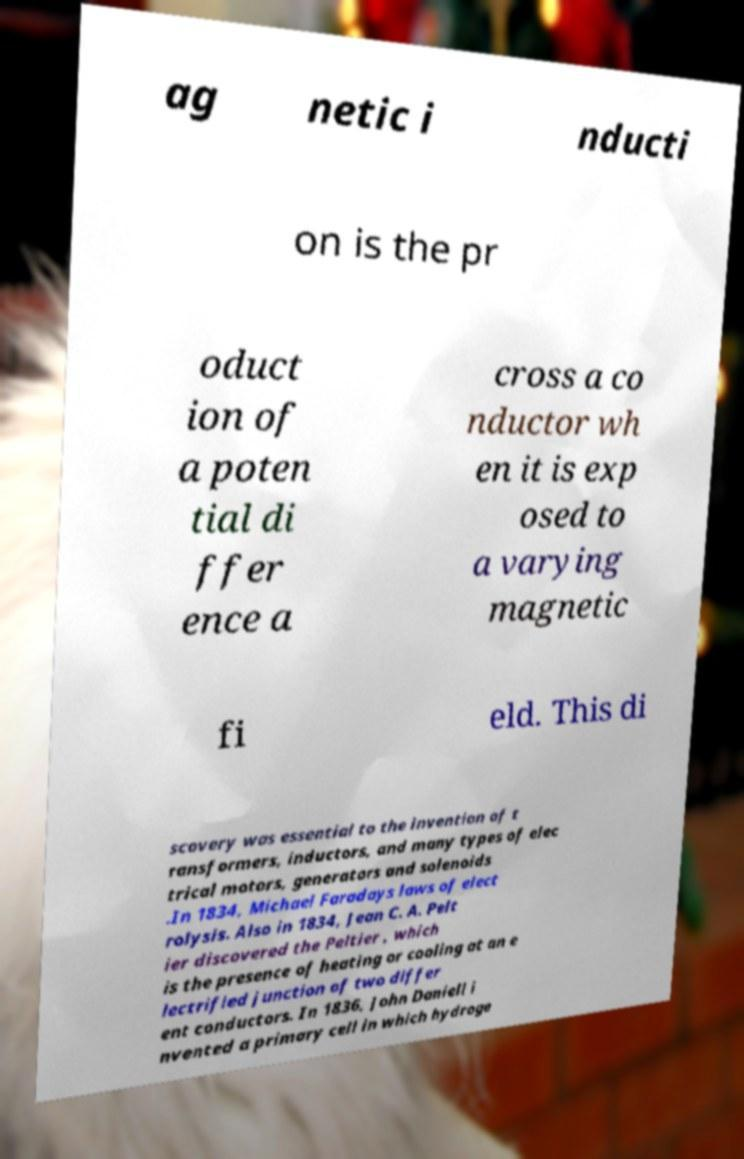Can you accurately transcribe the text from the provided image for me? ag netic i nducti on is the pr oduct ion of a poten tial di ffer ence a cross a co nductor wh en it is exp osed to a varying magnetic fi eld. This di scovery was essential to the invention of t ransformers, inductors, and many types of elec trical motors, generators and solenoids .In 1834, Michael Faradays laws of elect rolysis. Also in 1834, Jean C. A. Pelt ier discovered the Peltier , which is the presence of heating or cooling at an e lectrified junction of two differ ent conductors. In 1836, John Daniell i nvented a primary cell in which hydroge 